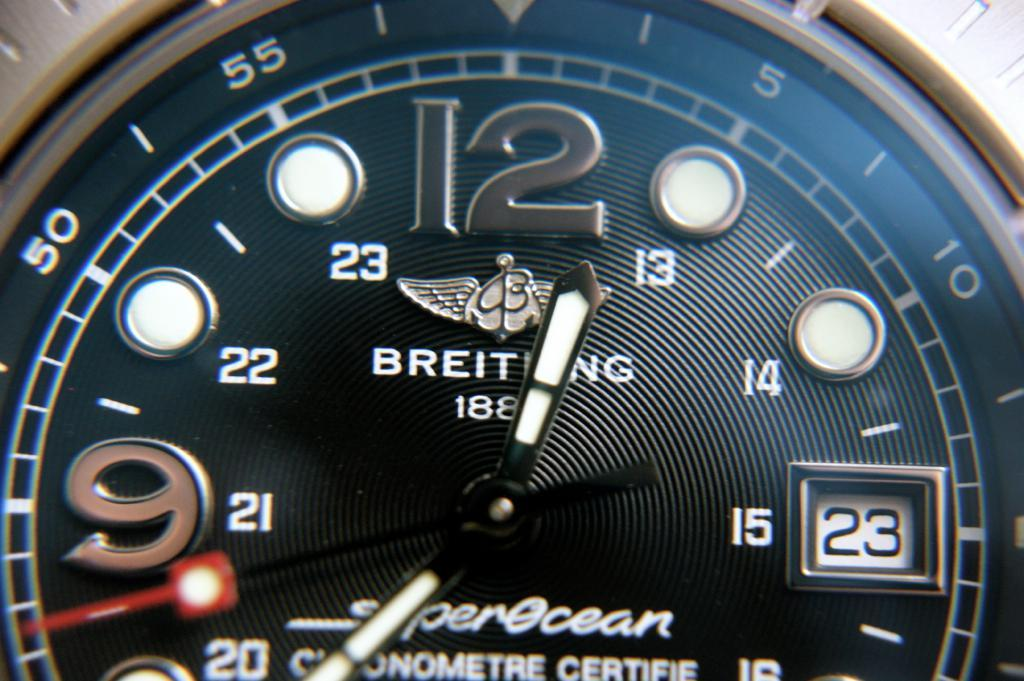<image>
Share a concise interpretation of the image provided. the word breiting that is on a watch 